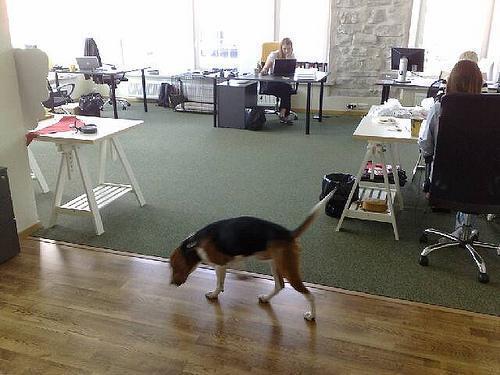How many people are in the photo?
Give a very brief answer. 2. How many cars are there?
Give a very brief answer. 0. 